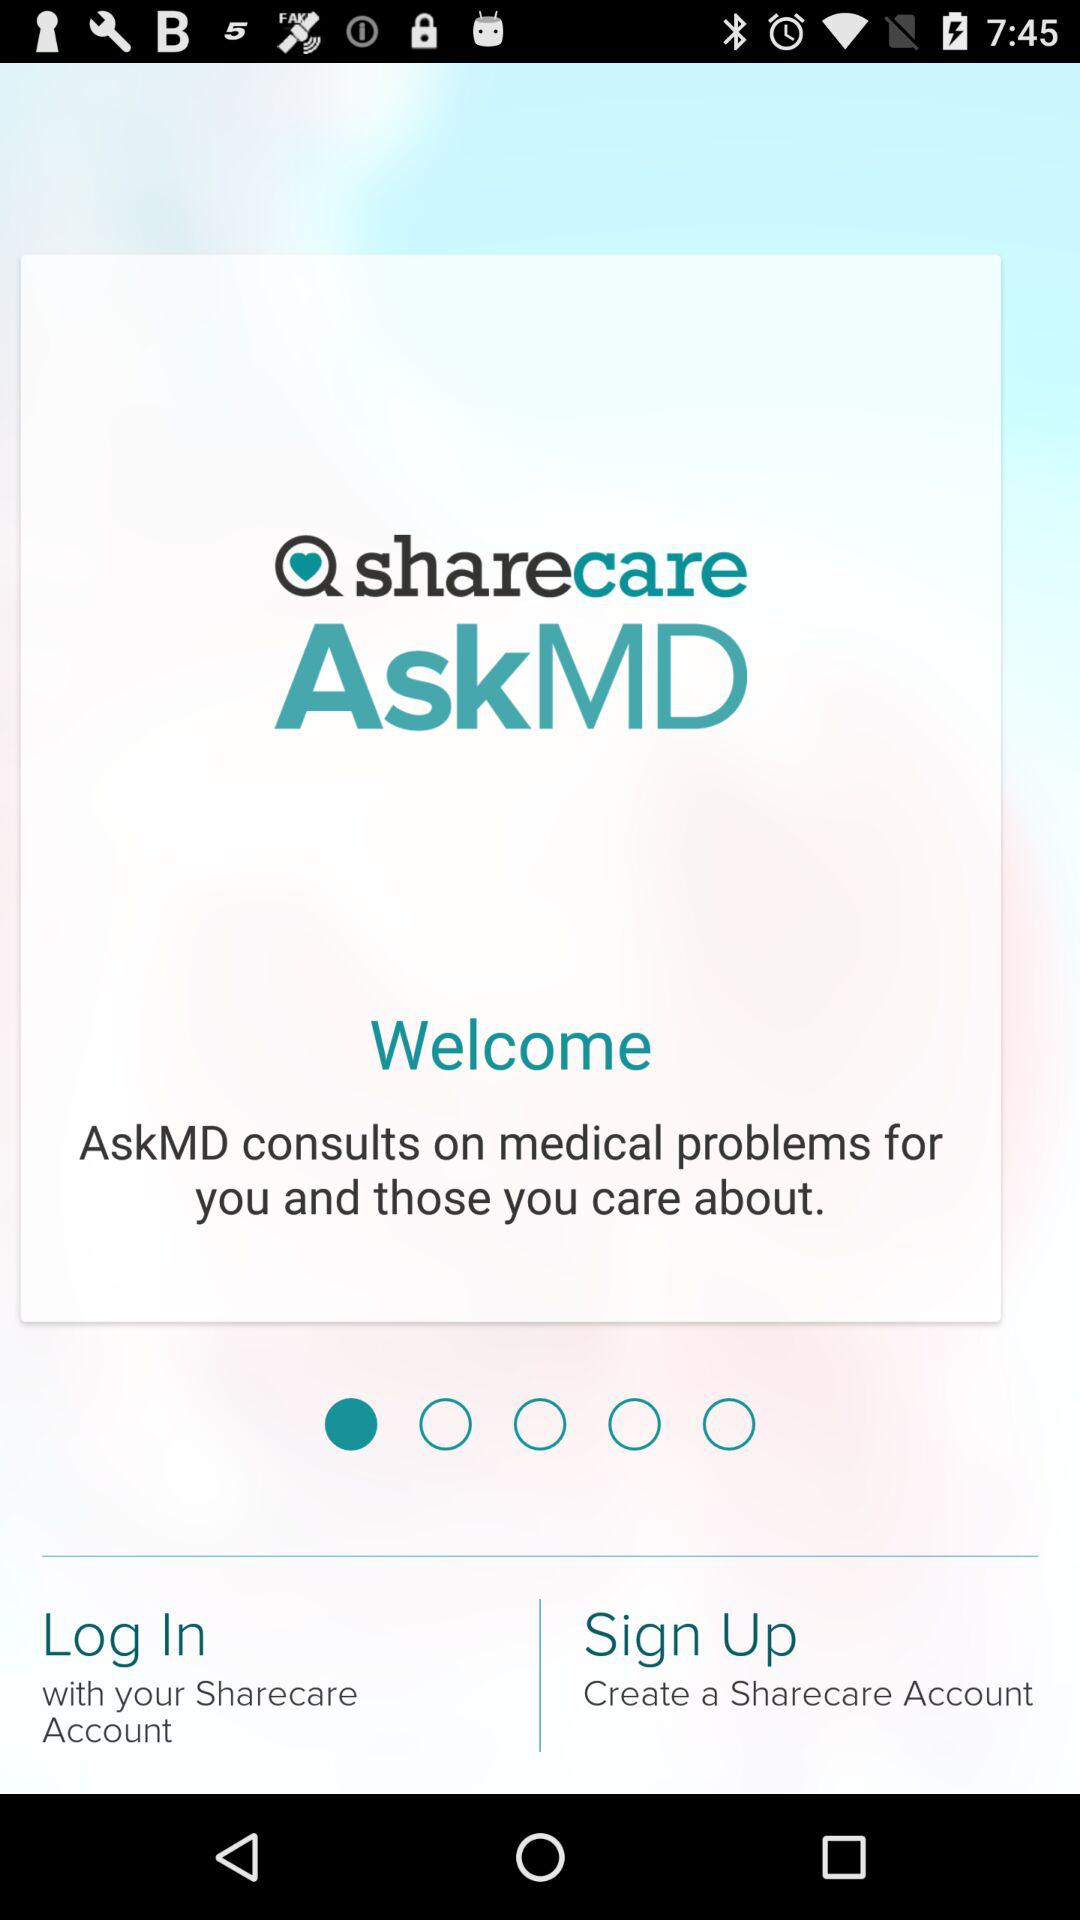What is the application name? The application name is "sharecare AskMD". 